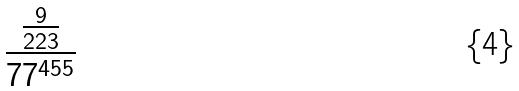<formula> <loc_0><loc_0><loc_500><loc_500>\frac { \frac { 9 } { 2 2 3 } } { 7 7 ^ { 4 5 5 } }</formula> 